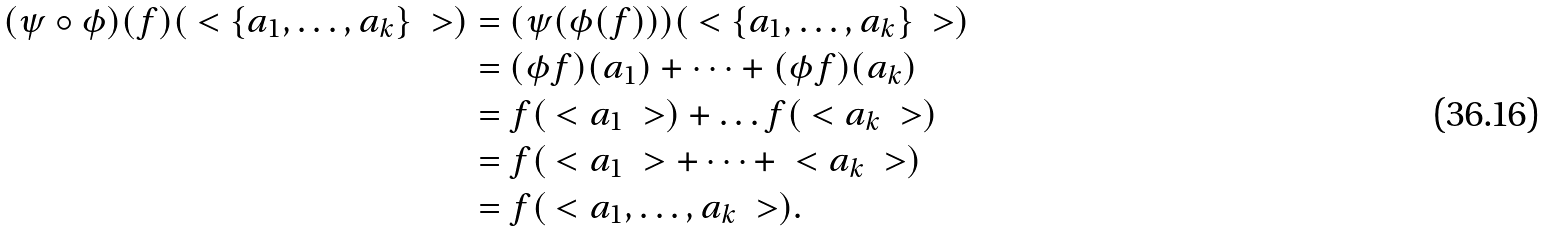Convert formula to latex. <formula><loc_0><loc_0><loc_500><loc_500>( \psi \circ \phi ) ( f ) ( \ < \{ a _ { 1 } , \dots , a _ { k } \} \ > ) & = ( \psi ( \phi ( f ) ) ) ( \ < \{ a _ { 1 } , \dots , a _ { k } \} \ > ) \\ & = ( \phi f ) ( a _ { 1 } ) + \dots + ( \phi f ) ( a _ { k } ) \\ & = f ( \ < a _ { 1 } \ > ) + \dots f ( \ < a _ { k } \ > ) \\ & = f ( \ < a _ { 1 } \ > + \dots + \ < a _ { k } \ > ) \\ & = f ( \ < a _ { 1 } , \dots , a _ { k } \ > ) .</formula> 